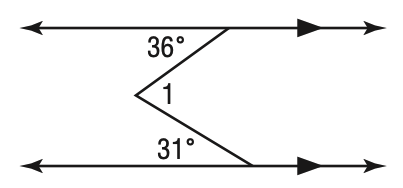Question: Find m \angle 1.
Choices:
A. 31
B. 36
C. 67
D. 77
Answer with the letter. Answer: C 